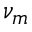Convert formula to latex. <formula><loc_0><loc_0><loc_500><loc_500>\nu _ { m }</formula> 